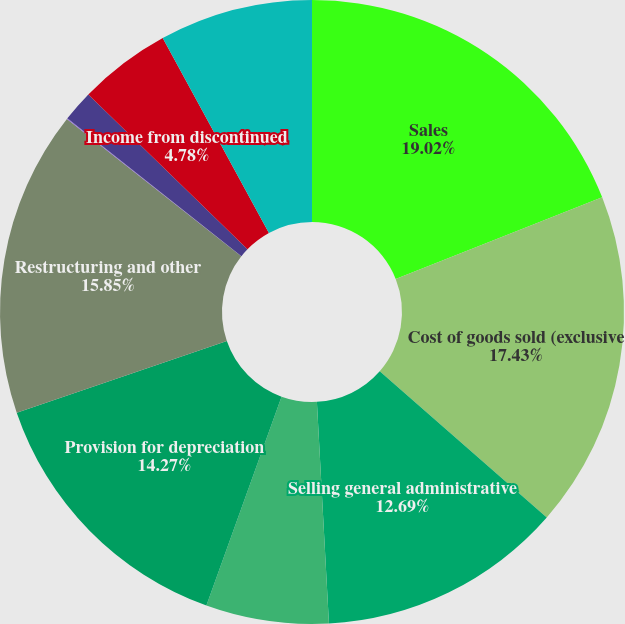Convert chart to OTSL. <chart><loc_0><loc_0><loc_500><loc_500><pie_chart><fcel>Sales<fcel>Cost of goods sold (exclusive<fcel>Selling general administrative<fcel>Research and development<fcel>Provision for depreciation<fcel>Restructuring and other<fcel>Interest expense<fcel>Other (income) expenses net<fcel>Income from discontinued<fcel>Provision for income taxes<nl><fcel>19.01%<fcel>17.43%<fcel>12.69%<fcel>6.36%<fcel>14.27%<fcel>15.85%<fcel>0.04%<fcel>1.62%<fcel>4.78%<fcel>7.94%<nl></chart> 